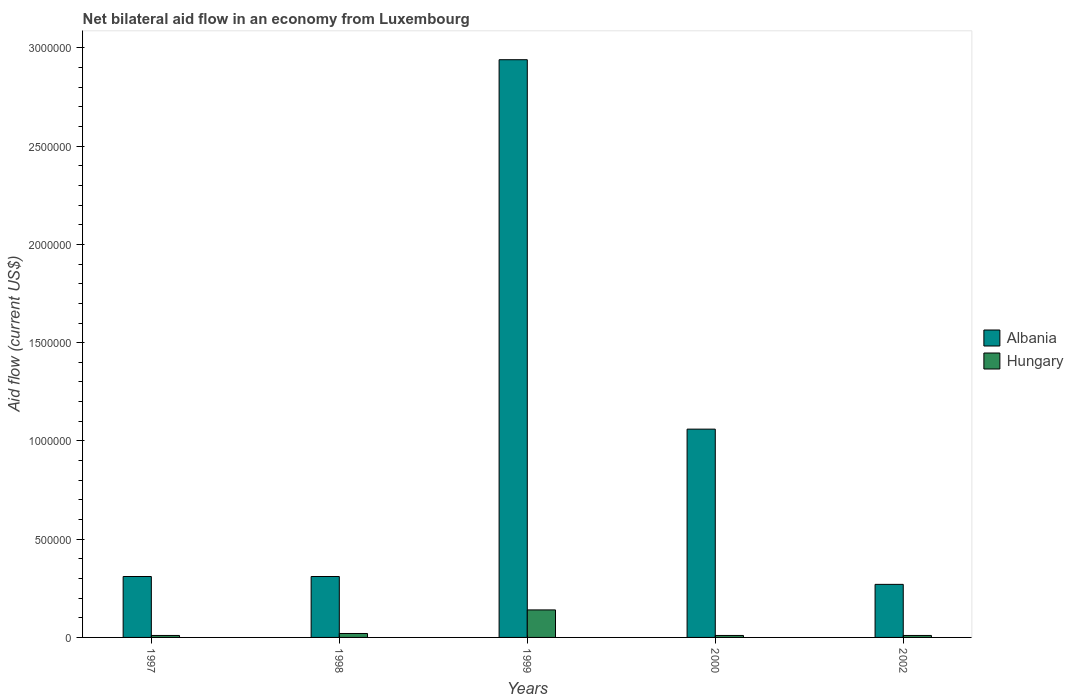How many groups of bars are there?
Give a very brief answer. 5. Are the number of bars per tick equal to the number of legend labels?
Your answer should be compact. Yes. Are the number of bars on each tick of the X-axis equal?
Provide a short and direct response. Yes. How many bars are there on the 3rd tick from the left?
Your answer should be very brief. 2. How many bars are there on the 2nd tick from the right?
Make the answer very short. 2. In how many cases, is the number of bars for a given year not equal to the number of legend labels?
Offer a very short reply. 0. What is the net bilateral aid flow in Albania in 1997?
Make the answer very short. 3.10e+05. Across all years, what is the maximum net bilateral aid flow in Albania?
Provide a short and direct response. 2.94e+06. In which year was the net bilateral aid flow in Albania minimum?
Your answer should be very brief. 2002. What is the total net bilateral aid flow in Albania in the graph?
Make the answer very short. 4.89e+06. What is the difference between the net bilateral aid flow in Hungary in 1998 and that in 1999?
Make the answer very short. -1.20e+05. What is the difference between the net bilateral aid flow in Hungary in 2000 and the net bilateral aid flow in Albania in 1998?
Keep it short and to the point. -3.00e+05. What is the average net bilateral aid flow in Hungary per year?
Your response must be concise. 3.80e+04. In how many years, is the net bilateral aid flow in Albania greater than 2800000 US$?
Your response must be concise. 1. What is the ratio of the net bilateral aid flow in Hungary in 1997 to that in 2000?
Give a very brief answer. 1. Is the difference between the net bilateral aid flow in Albania in 1997 and 1999 greater than the difference between the net bilateral aid flow in Hungary in 1997 and 1999?
Provide a succinct answer. No. What is the difference between the highest and the second highest net bilateral aid flow in Hungary?
Your answer should be very brief. 1.20e+05. In how many years, is the net bilateral aid flow in Albania greater than the average net bilateral aid flow in Albania taken over all years?
Your response must be concise. 2. Is the sum of the net bilateral aid flow in Albania in 1998 and 1999 greater than the maximum net bilateral aid flow in Hungary across all years?
Your response must be concise. Yes. What does the 2nd bar from the left in 1999 represents?
Give a very brief answer. Hungary. What does the 2nd bar from the right in 2000 represents?
Offer a very short reply. Albania. How many years are there in the graph?
Your answer should be compact. 5. Does the graph contain any zero values?
Your answer should be very brief. No. What is the title of the graph?
Give a very brief answer. Net bilateral aid flow in an economy from Luxembourg. What is the Aid flow (current US$) of Albania in 1999?
Keep it short and to the point. 2.94e+06. What is the Aid flow (current US$) of Albania in 2000?
Ensure brevity in your answer.  1.06e+06. Across all years, what is the maximum Aid flow (current US$) in Albania?
Your answer should be very brief. 2.94e+06. Across all years, what is the minimum Aid flow (current US$) of Hungary?
Make the answer very short. 10000. What is the total Aid flow (current US$) in Albania in the graph?
Your answer should be very brief. 4.89e+06. What is the total Aid flow (current US$) in Hungary in the graph?
Ensure brevity in your answer.  1.90e+05. What is the difference between the Aid flow (current US$) of Albania in 1997 and that in 1999?
Your answer should be very brief. -2.63e+06. What is the difference between the Aid flow (current US$) of Albania in 1997 and that in 2000?
Your response must be concise. -7.50e+05. What is the difference between the Aid flow (current US$) of Albania in 1997 and that in 2002?
Keep it short and to the point. 4.00e+04. What is the difference between the Aid flow (current US$) of Hungary in 1997 and that in 2002?
Provide a short and direct response. 0. What is the difference between the Aid flow (current US$) in Albania in 1998 and that in 1999?
Provide a succinct answer. -2.63e+06. What is the difference between the Aid flow (current US$) in Hungary in 1998 and that in 1999?
Ensure brevity in your answer.  -1.20e+05. What is the difference between the Aid flow (current US$) of Albania in 1998 and that in 2000?
Make the answer very short. -7.50e+05. What is the difference between the Aid flow (current US$) of Hungary in 1998 and that in 2000?
Offer a terse response. 10000. What is the difference between the Aid flow (current US$) in Albania in 1998 and that in 2002?
Your answer should be compact. 4.00e+04. What is the difference between the Aid flow (current US$) in Hungary in 1998 and that in 2002?
Your answer should be compact. 10000. What is the difference between the Aid flow (current US$) in Albania in 1999 and that in 2000?
Offer a terse response. 1.88e+06. What is the difference between the Aid flow (current US$) in Albania in 1999 and that in 2002?
Keep it short and to the point. 2.67e+06. What is the difference between the Aid flow (current US$) of Hungary in 1999 and that in 2002?
Your response must be concise. 1.30e+05. What is the difference between the Aid flow (current US$) of Albania in 2000 and that in 2002?
Offer a terse response. 7.90e+05. What is the difference between the Aid flow (current US$) in Albania in 1997 and the Aid flow (current US$) in Hungary in 1998?
Keep it short and to the point. 2.90e+05. What is the difference between the Aid flow (current US$) of Albania in 1998 and the Aid flow (current US$) of Hungary in 1999?
Provide a succinct answer. 1.70e+05. What is the difference between the Aid flow (current US$) in Albania in 1998 and the Aid flow (current US$) in Hungary in 2000?
Make the answer very short. 3.00e+05. What is the difference between the Aid flow (current US$) in Albania in 1999 and the Aid flow (current US$) in Hungary in 2000?
Ensure brevity in your answer.  2.93e+06. What is the difference between the Aid flow (current US$) in Albania in 1999 and the Aid flow (current US$) in Hungary in 2002?
Make the answer very short. 2.93e+06. What is the difference between the Aid flow (current US$) of Albania in 2000 and the Aid flow (current US$) of Hungary in 2002?
Your response must be concise. 1.05e+06. What is the average Aid flow (current US$) in Albania per year?
Provide a succinct answer. 9.78e+05. What is the average Aid flow (current US$) in Hungary per year?
Make the answer very short. 3.80e+04. In the year 1999, what is the difference between the Aid flow (current US$) of Albania and Aid flow (current US$) of Hungary?
Your response must be concise. 2.80e+06. In the year 2000, what is the difference between the Aid flow (current US$) of Albania and Aid flow (current US$) of Hungary?
Your answer should be very brief. 1.05e+06. What is the ratio of the Aid flow (current US$) in Albania in 1997 to that in 1998?
Your response must be concise. 1. What is the ratio of the Aid flow (current US$) of Albania in 1997 to that in 1999?
Your answer should be very brief. 0.11. What is the ratio of the Aid flow (current US$) in Hungary in 1997 to that in 1999?
Provide a short and direct response. 0.07. What is the ratio of the Aid flow (current US$) of Albania in 1997 to that in 2000?
Keep it short and to the point. 0.29. What is the ratio of the Aid flow (current US$) in Hungary in 1997 to that in 2000?
Your answer should be compact. 1. What is the ratio of the Aid flow (current US$) of Albania in 1997 to that in 2002?
Provide a short and direct response. 1.15. What is the ratio of the Aid flow (current US$) of Hungary in 1997 to that in 2002?
Your answer should be compact. 1. What is the ratio of the Aid flow (current US$) in Albania in 1998 to that in 1999?
Provide a short and direct response. 0.11. What is the ratio of the Aid flow (current US$) of Hungary in 1998 to that in 1999?
Offer a very short reply. 0.14. What is the ratio of the Aid flow (current US$) of Albania in 1998 to that in 2000?
Keep it short and to the point. 0.29. What is the ratio of the Aid flow (current US$) of Albania in 1998 to that in 2002?
Make the answer very short. 1.15. What is the ratio of the Aid flow (current US$) in Hungary in 1998 to that in 2002?
Your answer should be compact. 2. What is the ratio of the Aid flow (current US$) in Albania in 1999 to that in 2000?
Offer a terse response. 2.77. What is the ratio of the Aid flow (current US$) of Albania in 1999 to that in 2002?
Provide a short and direct response. 10.89. What is the ratio of the Aid flow (current US$) in Hungary in 1999 to that in 2002?
Provide a succinct answer. 14. What is the ratio of the Aid flow (current US$) of Albania in 2000 to that in 2002?
Make the answer very short. 3.93. What is the ratio of the Aid flow (current US$) of Hungary in 2000 to that in 2002?
Your response must be concise. 1. What is the difference between the highest and the second highest Aid flow (current US$) in Albania?
Make the answer very short. 1.88e+06. What is the difference between the highest and the second highest Aid flow (current US$) in Hungary?
Your response must be concise. 1.20e+05. What is the difference between the highest and the lowest Aid flow (current US$) in Albania?
Provide a succinct answer. 2.67e+06. 